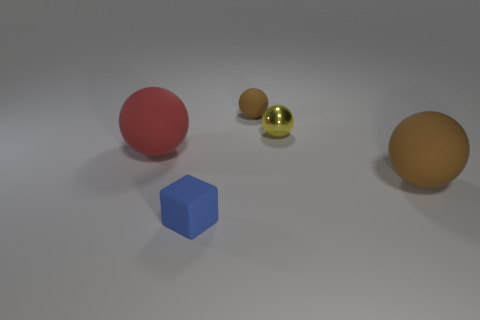Subtract all tiny brown matte balls. How many balls are left? 3 Subtract all purple balls. Subtract all purple cubes. How many balls are left? 4 Add 1 brown rubber objects. How many objects exist? 6 Subtract all balls. How many objects are left? 1 Add 2 tiny cyan matte objects. How many tiny cyan matte objects exist? 2 Subtract 1 red balls. How many objects are left? 4 Subtract all blue shiny spheres. Subtract all tiny matte spheres. How many objects are left? 4 Add 1 big matte things. How many big matte things are left? 3 